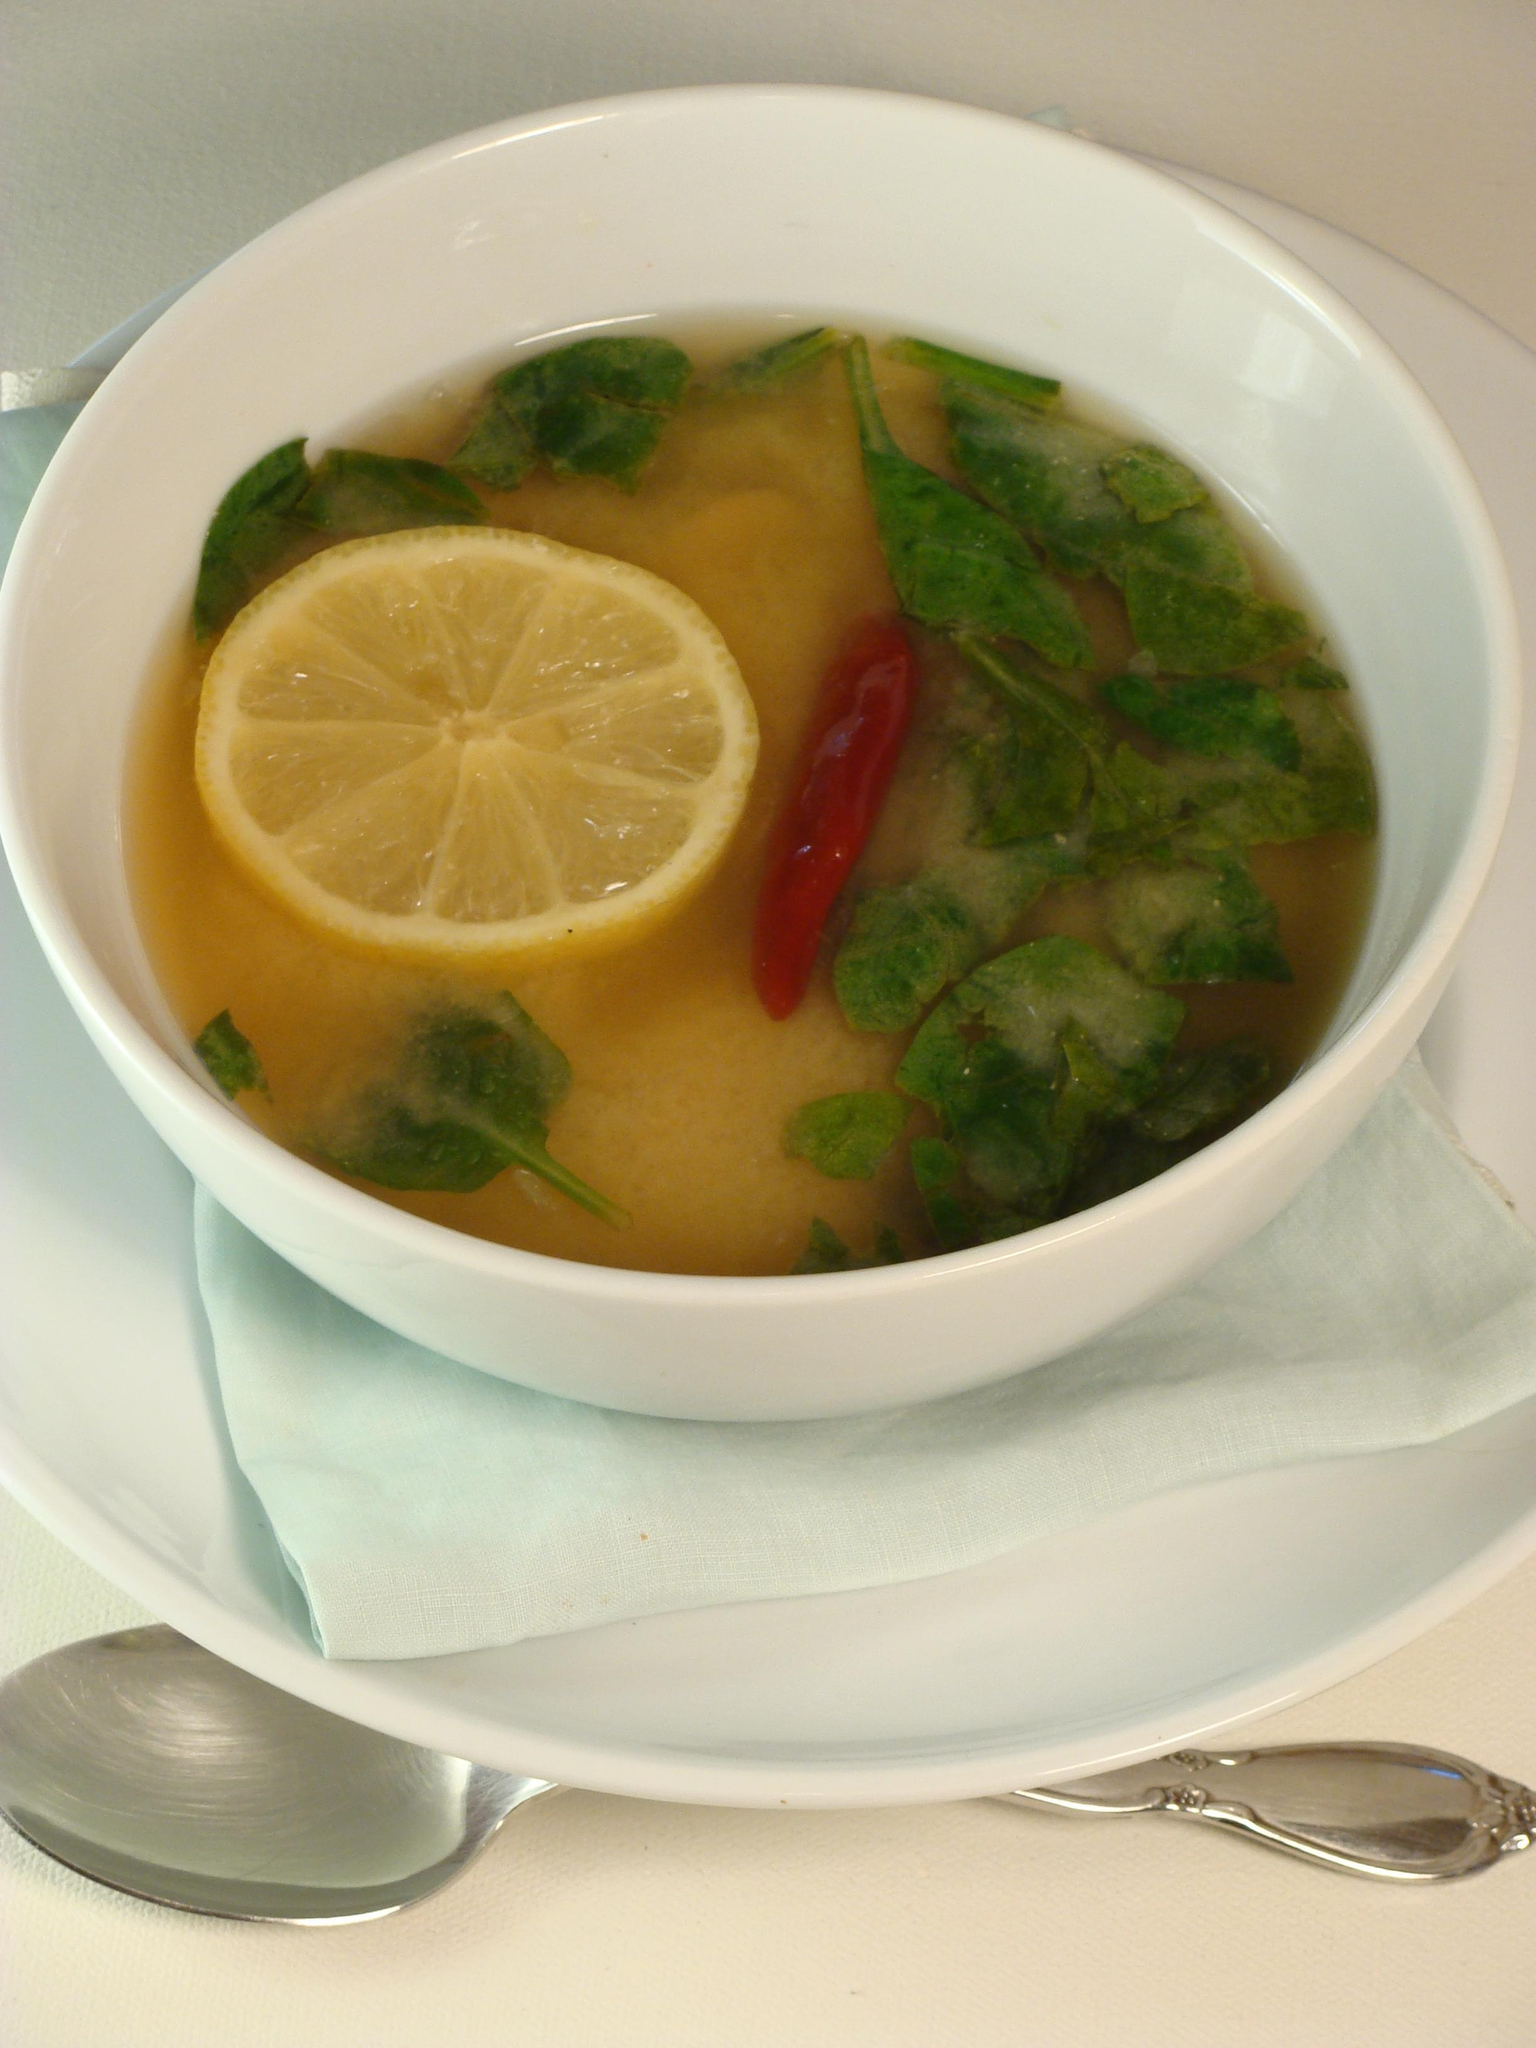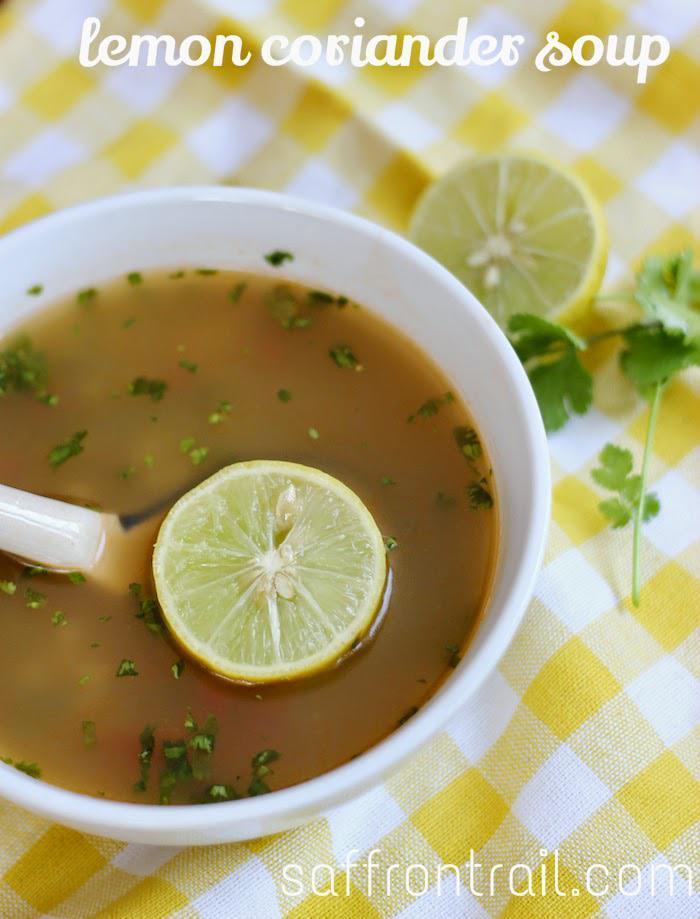The first image is the image on the left, the second image is the image on the right. For the images shown, is this caption "A white spoon is sitting in the bowl in one of the images." true? Answer yes or no. Yes. The first image is the image on the left, the second image is the image on the right. Evaluate the accuracy of this statement regarding the images: "A silverware spoon is lying on a flat surface nex to a white bowl containing soup.". Is it true? Answer yes or no. Yes. 